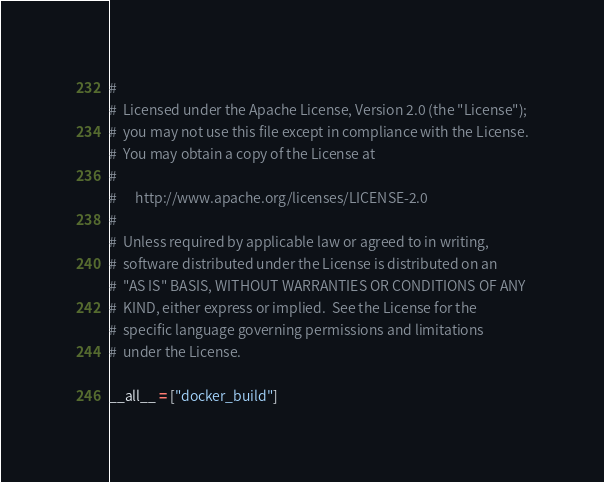Convert code to text. <code><loc_0><loc_0><loc_500><loc_500><_Python_>#
#  Licensed under the Apache License, Version 2.0 (the "License");
#  you may not use this file except in compliance with the License.
#  You may obtain a copy of the License at
#
#      http://www.apache.org/licenses/LICENSE-2.0
#
#  Unless required by applicable law or agreed to in writing,
#  software distributed under the License is distributed on an
#  "AS IS" BASIS, WITHOUT WARRANTIES OR CONDITIONS OF ANY
#  KIND, either express or implied.  See the License for the
#  specific language governing permissions and limitations
#  under the License.

__all__ = ["docker_build"]
</code> 